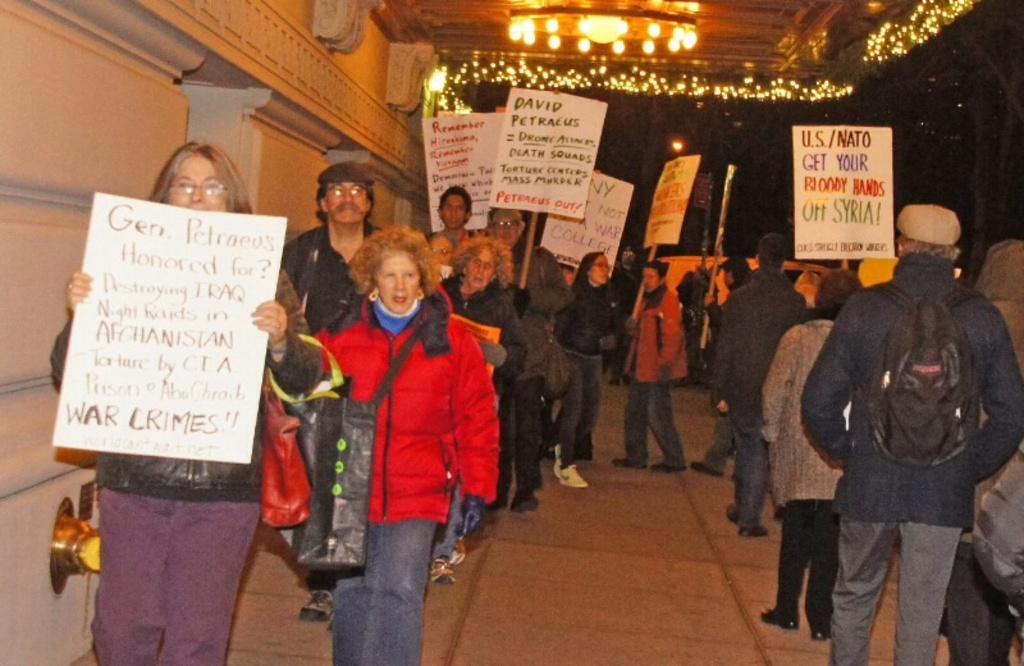What are the people in the image doing? The people in the image are walking. What are the people holding while walking? The people are holding a poster. What is on the left side of the image? There is a wall on the left side of the image. What can be seen at the top of the image? There is a light visible at the top of the image. What type of plants are growing on the people's underwear in the image? There are no plants or underwear visible in the image; the people are holding a poster. 